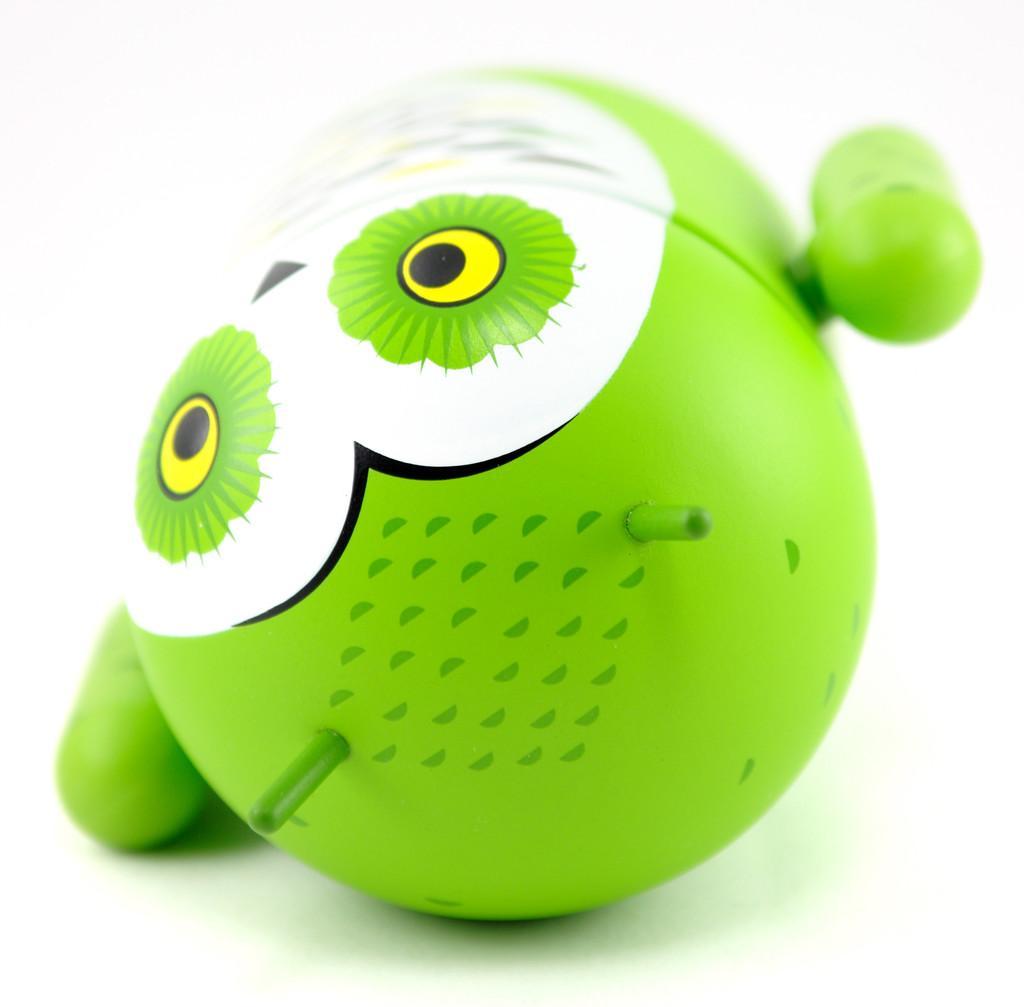How would you summarize this image in a sentence or two? In this picture we can see a toy. 